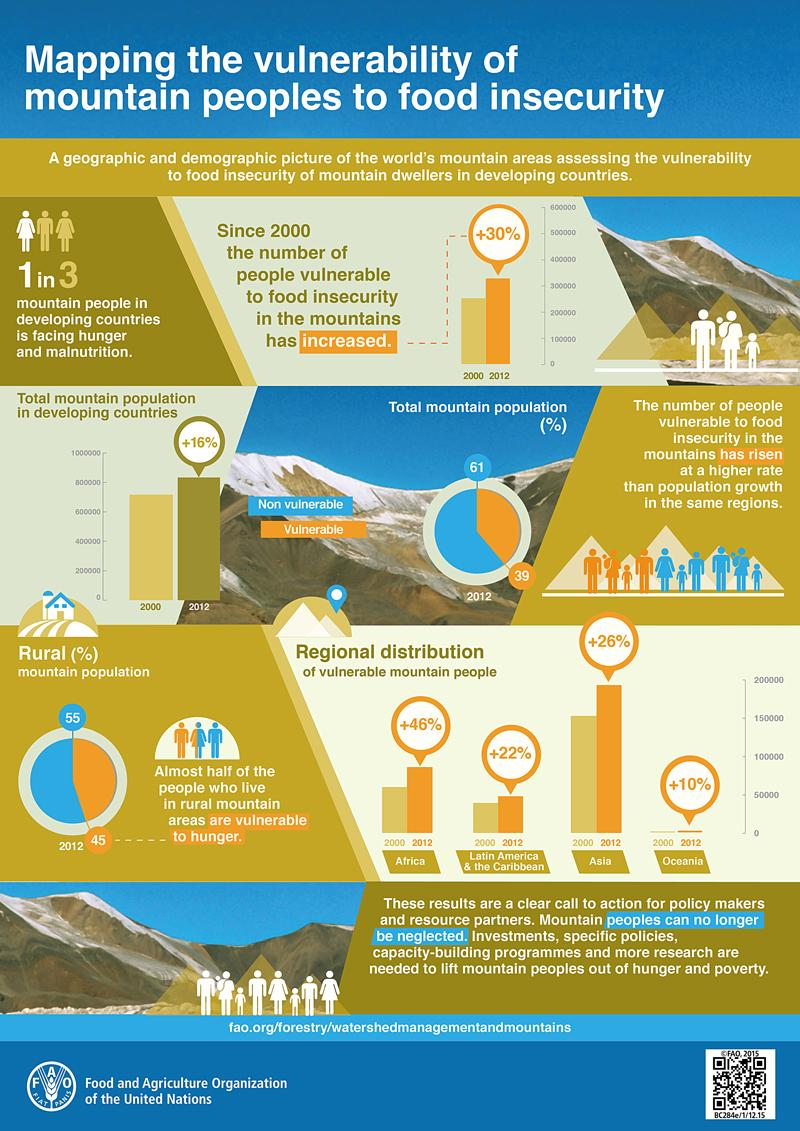Point out several critical features in this image. According to data from 2012, the percentage of vulnerable mountain people in Asia has increased by +26%. In 2012, only 61% of the mountain population in developing countries were non-vulnerable to hunger, according to statistics. In 2012, a significant percentage of the mountain population in developing countries was vulnerable to hunger, amounting to 39%. In 2012, there was a 46% increase in the number of vulnerable mountain people in Africa. In 2012, approximately 45% of people living in rural mountain areas of developing countries were vulnerable to hunger. 